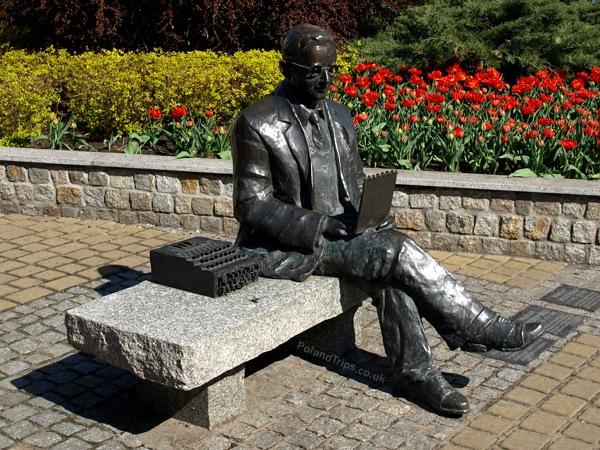What color is the bench?
Be succinct. Gray. What is sitting next to the man?
Short answer required. Typewriter. Is that a real person sitting on the bench?
Write a very short answer. No. 